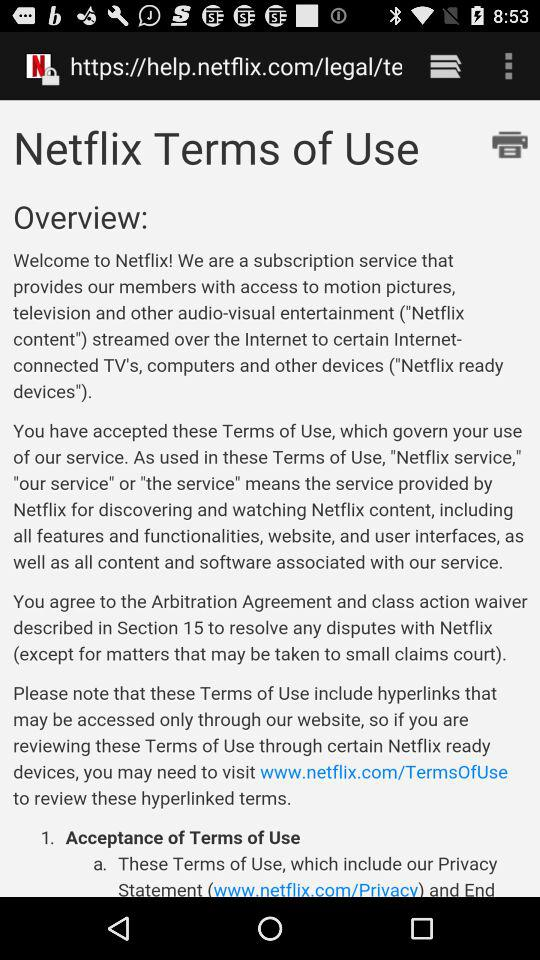How many sections are there in the Terms of Use?
Answer the question using a single word or phrase. 15 